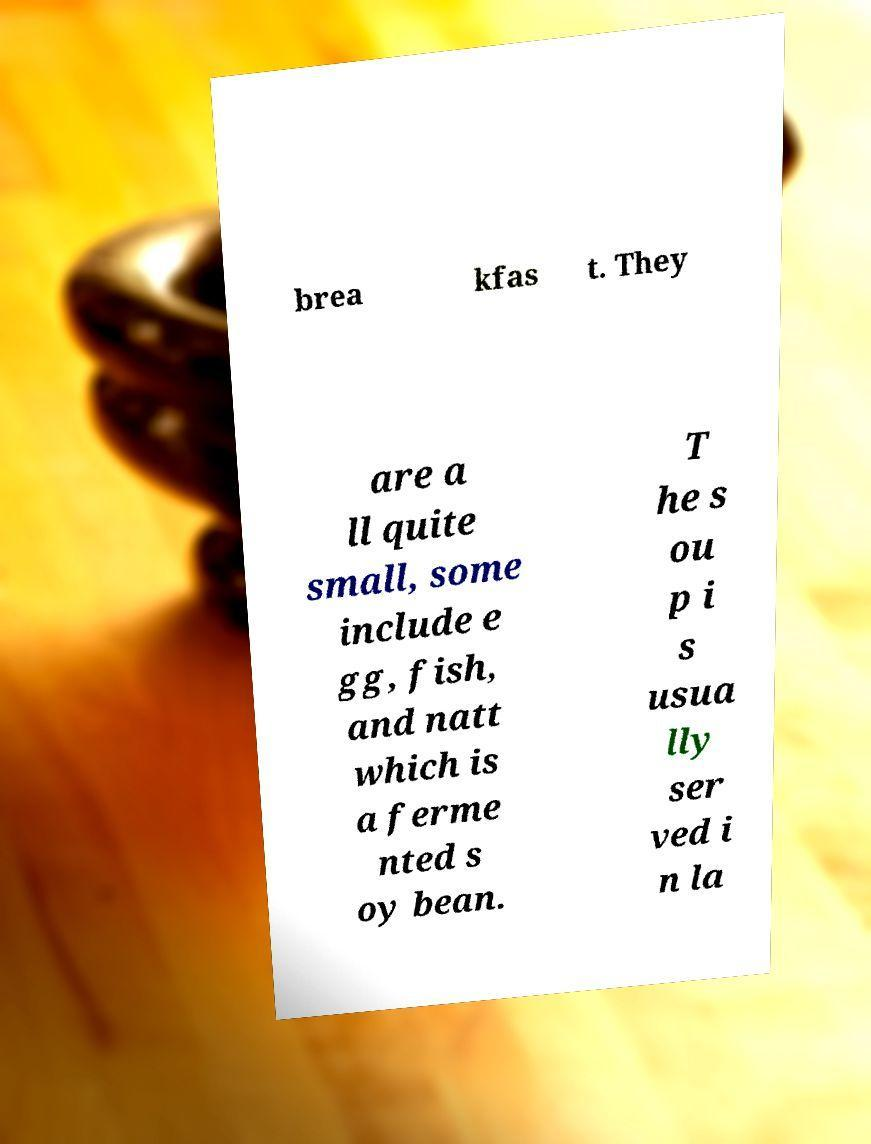Could you extract and type out the text from this image? brea kfas t. They are a ll quite small, some include e gg, fish, and natt which is a ferme nted s oy bean. T he s ou p i s usua lly ser ved i n la 